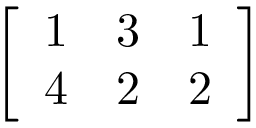<formula> <loc_0><loc_0><loc_500><loc_500>\left [ \begin{array} { l l l } { 1 } & { 3 } & { 1 } \\ { 4 } & { 2 } & { 2 } \end{array} \right ]</formula> 